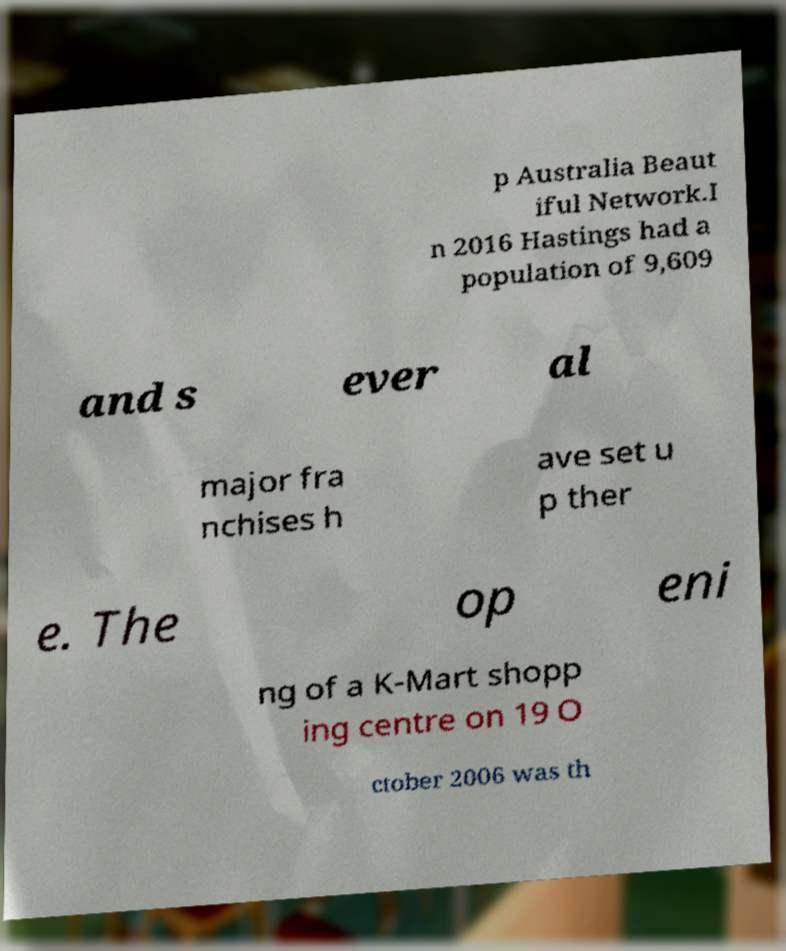Could you extract and type out the text from this image? p Australia Beaut iful Network.I n 2016 Hastings had a population of 9,609 and s ever al major fra nchises h ave set u p ther e. The op eni ng of a K-Mart shopp ing centre on 19 O ctober 2006 was th 